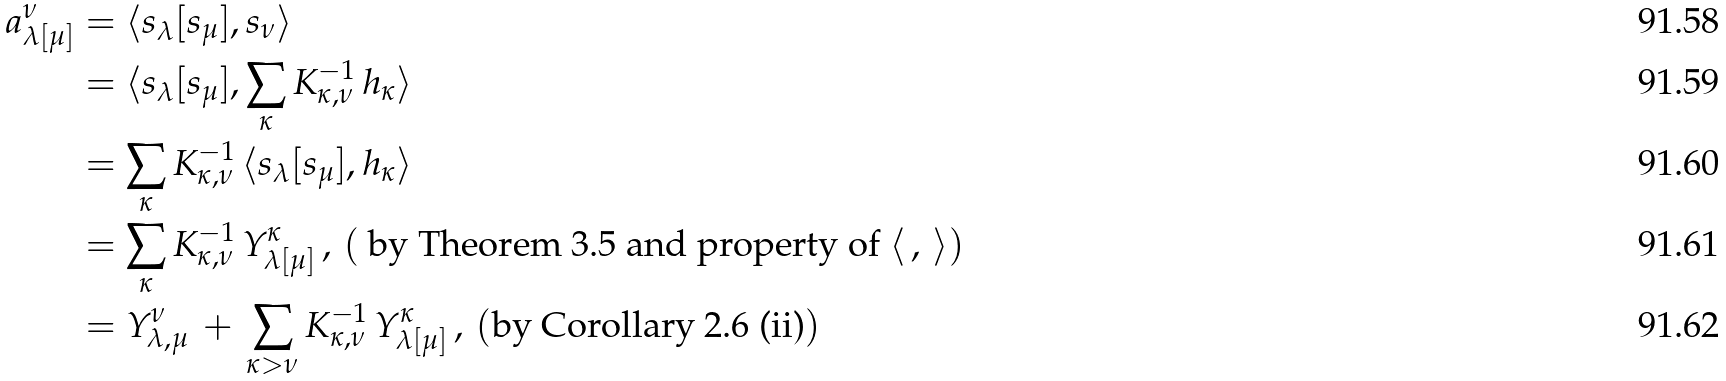Convert formula to latex. <formula><loc_0><loc_0><loc_500><loc_500>a _ { \lambda [ \mu ] } ^ { \nu } & = \langle s _ { \lambda } [ s _ { \mu } ] , s _ { \nu } \rangle \\ & = \langle s _ { \lambda } [ s _ { \mu } ] , \sum _ { \kappa } K _ { \kappa , \nu } ^ { - 1 } \, h _ { \kappa } \rangle \\ & = \sum _ { \kappa } K _ { \kappa , \nu } ^ { - 1 } \, \langle s _ { \lambda } [ s _ { \mu } ] , h _ { \kappa } \rangle \\ & = \sum _ { \kappa } K _ { \kappa , \nu } ^ { - 1 } \, Y _ { \lambda [ \mu ] } ^ { \kappa } \, , \, ( \text { by Theorem 3.5 and property of } \langle \, , \, \rangle ) \\ & = Y _ { \lambda , \mu } ^ { \nu } \, + \, \sum _ { \kappa > \nu } K _ { \kappa , \nu } ^ { - 1 } \, Y _ { \lambda [ \mu ] } ^ { \kappa } \, , \, ( \text {by Corollary 2.6 (ii)} )</formula> 